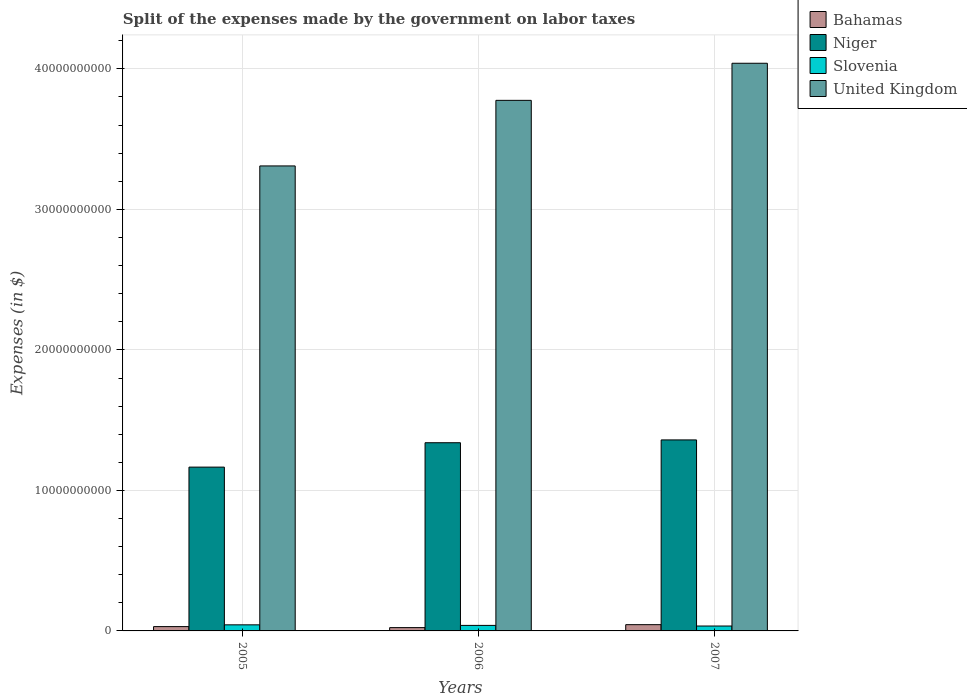How many bars are there on the 1st tick from the left?
Your answer should be compact. 4. How many bars are there on the 2nd tick from the right?
Your response must be concise. 4. What is the label of the 3rd group of bars from the left?
Keep it short and to the point. 2007. What is the expenses made by the government on labor taxes in Bahamas in 2006?
Keep it short and to the point. 2.35e+08. Across all years, what is the maximum expenses made by the government on labor taxes in Slovenia?
Your response must be concise. 4.33e+08. Across all years, what is the minimum expenses made by the government on labor taxes in Niger?
Give a very brief answer. 1.17e+1. In which year was the expenses made by the government on labor taxes in Niger minimum?
Offer a terse response. 2005. What is the total expenses made by the government on labor taxes in Niger in the graph?
Keep it short and to the point. 3.86e+1. What is the difference between the expenses made by the government on labor taxes in Bahamas in 2005 and that in 2007?
Keep it short and to the point. -1.39e+08. What is the difference between the expenses made by the government on labor taxes in United Kingdom in 2007 and the expenses made by the government on labor taxes in Niger in 2006?
Your answer should be very brief. 2.70e+1. What is the average expenses made by the government on labor taxes in Slovenia per year?
Offer a very short reply. 3.91e+08. In the year 2006, what is the difference between the expenses made by the government on labor taxes in Bahamas and expenses made by the government on labor taxes in Slovenia?
Ensure brevity in your answer.  -1.58e+08. What is the ratio of the expenses made by the government on labor taxes in United Kingdom in 2006 to that in 2007?
Keep it short and to the point. 0.93. Is the expenses made by the government on labor taxes in Niger in 2006 less than that in 2007?
Ensure brevity in your answer.  Yes. Is the difference between the expenses made by the government on labor taxes in Bahamas in 2005 and 2006 greater than the difference between the expenses made by the government on labor taxes in Slovenia in 2005 and 2006?
Your response must be concise. Yes. What is the difference between the highest and the second highest expenses made by the government on labor taxes in United Kingdom?
Give a very brief answer. 2.64e+09. What is the difference between the highest and the lowest expenses made by the government on labor taxes in United Kingdom?
Keep it short and to the point. 7.31e+09. In how many years, is the expenses made by the government on labor taxes in Bahamas greater than the average expenses made by the government on labor taxes in Bahamas taken over all years?
Offer a very short reply. 1. Is it the case that in every year, the sum of the expenses made by the government on labor taxes in United Kingdom and expenses made by the government on labor taxes in Slovenia is greater than the sum of expenses made by the government on labor taxes in Niger and expenses made by the government on labor taxes in Bahamas?
Offer a terse response. Yes. What does the 4th bar from the right in 2006 represents?
Offer a very short reply. Bahamas. How many years are there in the graph?
Ensure brevity in your answer.  3. Does the graph contain any zero values?
Your answer should be very brief. No. Does the graph contain grids?
Your answer should be compact. Yes. Where does the legend appear in the graph?
Provide a short and direct response. Top right. How many legend labels are there?
Your response must be concise. 4. What is the title of the graph?
Ensure brevity in your answer.  Split of the expenses made by the government on labor taxes. Does "Monaco" appear as one of the legend labels in the graph?
Give a very brief answer. No. What is the label or title of the Y-axis?
Offer a terse response. Expenses (in $). What is the Expenses (in $) of Bahamas in 2005?
Your response must be concise. 3.07e+08. What is the Expenses (in $) in Niger in 2005?
Ensure brevity in your answer.  1.17e+1. What is the Expenses (in $) of Slovenia in 2005?
Your answer should be very brief. 4.33e+08. What is the Expenses (in $) of United Kingdom in 2005?
Your answer should be compact. 3.31e+1. What is the Expenses (in $) of Bahamas in 2006?
Ensure brevity in your answer.  2.35e+08. What is the Expenses (in $) in Niger in 2006?
Ensure brevity in your answer.  1.34e+1. What is the Expenses (in $) of Slovenia in 2006?
Your response must be concise. 3.93e+08. What is the Expenses (in $) of United Kingdom in 2006?
Offer a very short reply. 3.78e+1. What is the Expenses (in $) in Bahamas in 2007?
Keep it short and to the point. 4.46e+08. What is the Expenses (in $) of Niger in 2007?
Ensure brevity in your answer.  1.36e+1. What is the Expenses (in $) of Slovenia in 2007?
Provide a short and direct response. 3.49e+08. What is the Expenses (in $) in United Kingdom in 2007?
Provide a succinct answer. 4.04e+1. Across all years, what is the maximum Expenses (in $) of Bahamas?
Give a very brief answer. 4.46e+08. Across all years, what is the maximum Expenses (in $) in Niger?
Offer a terse response. 1.36e+1. Across all years, what is the maximum Expenses (in $) in Slovenia?
Keep it short and to the point. 4.33e+08. Across all years, what is the maximum Expenses (in $) of United Kingdom?
Your answer should be very brief. 4.04e+1. Across all years, what is the minimum Expenses (in $) in Bahamas?
Offer a terse response. 2.35e+08. Across all years, what is the minimum Expenses (in $) of Niger?
Give a very brief answer. 1.17e+1. Across all years, what is the minimum Expenses (in $) of Slovenia?
Your answer should be compact. 3.49e+08. Across all years, what is the minimum Expenses (in $) of United Kingdom?
Offer a very short reply. 3.31e+1. What is the total Expenses (in $) in Bahamas in the graph?
Give a very brief answer. 9.88e+08. What is the total Expenses (in $) in Niger in the graph?
Offer a very short reply. 3.86e+1. What is the total Expenses (in $) in Slovenia in the graph?
Give a very brief answer. 1.17e+09. What is the total Expenses (in $) in United Kingdom in the graph?
Make the answer very short. 1.11e+11. What is the difference between the Expenses (in $) in Bahamas in 2005 and that in 2006?
Give a very brief answer. 7.18e+07. What is the difference between the Expenses (in $) of Niger in 2005 and that in 2006?
Your response must be concise. -1.74e+09. What is the difference between the Expenses (in $) of Slovenia in 2005 and that in 2006?
Ensure brevity in your answer.  3.99e+07. What is the difference between the Expenses (in $) in United Kingdom in 2005 and that in 2006?
Keep it short and to the point. -4.67e+09. What is the difference between the Expenses (in $) in Bahamas in 2005 and that in 2007?
Offer a very short reply. -1.39e+08. What is the difference between the Expenses (in $) of Niger in 2005 and that in 2007?
Keep it short and to the point. -1.94e+09. What is the difference between the Expenses (in $) in Slovenia in 2005 and that in 2007?
Make the answer very short. 8.39e+07. What is the difference between the Expenses (in $) of United Kingdom in 2005 and that in 2007?
Offer a very short reply. -7.31e+09. What is the difference between the Expenses (in $) of Bahamas in 2006 and that in 2007?
Your response must be concise. -2.10e+08. What is the difference between the Expenses (in $) of Niger in 2006 and that in 2007?
Provide a short and direct response. -2.01e+08. What is the difference between the Expenses (in $) in Slovenia in 2006 and that in 2007?
Offer a terse response. 4.41e+07. What is the difference between the Expenses (in $) of United Kingdom in 2006 and that in 2007?
Offer a very short reply. -2.64e+09. What is the difference between the Expenses (in $) in Bahamas in 2005 and the Expenses (in $) in Niger in 2006?
Keep it short and to the point. -1.31e+1. What is the difference between the Expenses (in $) of Bahamas in 2005 and the Expenses (in $) of Slovenia in 2006?
Keep it short and to the point. -8.58e+07. What is the difference between the Expenses (in $) of Bahamas in 2005 and the Expenses (in $) of United Kingdom in 2006?
Offer a terse response. -3.75e+1. What is the difference between the Expenses (in $) of Niger in 2005 and the Expenses (in $) of Slovenia in 2006?
Your response must be concise. 1.13e+1. What is the difference between the Expenses (in $) in Niger in 2005 and the Expenses (in $) in United Kingdom in 2006?
Offer a very short reply. -2.61e+1. What is the difference between the Expenses (in $) of Slovenia in 2005 and the Expenses (in $) of United Kingdom in 2006?
Your answer should be compact. -3.73e+1. What is the difference between the Expenses (in $) in Bahamas in 2005 and the Expenses (in $) in Niger in 2007?
Offer a very short reply. -1.33e+1. What is the difference between the Expenses (in $) in Bahamas in 2005 and the Expenses (in $) in Slovenia in 2007?
Provide a succinct answer. -4.17e+07. What is the difference between the Expenses (in $) in Bahamas in 2005 and the Expenses (in $) in United Kingdom in 2007?
Your answer should be compact. -4.01e+1. What is the difference between the Expenses (in $) of Niger in 2005 and the Expenses (in $) of Slovenia in 2007?
Your answer should be very brief. 1.13e+1. What is the difference between the Expenses (in $) of Niger in 2005 and the Expenses (in $) of United Kingdom in 2007?
Your answer should be compact. -2.87e+1. What is the difference between the Expenses (in $) of Slovenia in 2005 and the Expenses (in $) of United Kingdom in 2007?
Your answer should be very brief. -4.00e+1. What is the difference between the Expenses (in $) of Bahamas in 2006 and the Expenses (in $) of Niger in 2007?
Provide a short and direct response. -1.34e+1. What is the difference between the Expenses (in $) in Bahamas in 2006 and the Expenses (in $) in Slovenia in 2007?
Your response must be concise. -1.14e+08. What is the difference between the Expenses (in $) in Bahamas in 2006 and the Expenses (in $) in United Kingdom in 2007?
Provide a succinct answer. -4.02e+1. What is the difference between the Expenses (in $) in Niger in 2006 and the Expenses (in $) in Slovenia in 2007?
Your response must be concise. 1.30e+1. What is the difference between the Expenses (in $) of Niger in 2006 and the Expenses (in $) of United Kingdom in 2007?
Ensure brevity in your answer.  -2.70e+1. What is the difference between the Expenses (in $) in Slovenia in 2006 and the Expenses (in $) in United Kingdom in 2007?
Provide a short and direct response. -4.00e+1. What is the average Expenses (in $) of Bahamas per year?
Your response must be concise. 3.29e+08. What is the average Expenses (in $) of Niger per year?
Your answer should be compact. 1.29e+1. What is the average Expenses (in $) of Slovenia per year?
Make the answer very short. 3.91e+08. What is the average Expenses (in $) in United Kingdom per year?
Make the answer very short. 3.71e+1. In the year 2005, what is the difference between the Expenses (in $) of Bahamas and Expenses (in $) of Niger?
Provide a short and direct response. -1.14e+1. In the year 2005, what is the difference between the Expenses (in $) in Bahamas and Expenses (in $) in Slovenia?
Give a very brief answer. -1.26e+08. In the year 2005, what is the difference between the Expenses (in $) of Bahamas and Expenses (in $) of United Kingdom?
Your answer should be compact. -3.28e+1. In the year 2005, what is the difference between the Expenses (in $) of Niger and Expenses (in $) of Slovenia?
Ensure brevity in your answer.  1.12e+1. In the year 2005, what is the difference between the Expenses (in $) in Niger and Expenses (in $) in United Kingdom?
Offer a very short reply. -2.14e+1. In the year 2005, what is the difference between the Expenses (in $) in Slovenia and Expenses (in $) in United Kingdom?
Give a very brief answer. -3.27e+1. In the year 2006, what is the difference between the Expenses (in $) in Bahamas and Expenses (in $) in Niger?
Provide a short and direct response. -1.32e+1. In the year 2006, what is the difference between the Expenses (in $) in Bahamas and Expenses (in $) in Slovenia?
Give a very brief answer. -1.58e+08. In the year 2006, what is the difference between the Expenses (in $) of Bahamas and Expenses (in $) of United Kingdom?
Your answer should be compact. -3.75e+1. In the year 2006, what is the difference between the Expenses (in $) of Niger and Expenses (in $) of Slovenia?
Your response must be concise. 1.30e+1. In the year 2006, what is the difference between the Expenses (in $) in Niger and Expenses (in $) in United Kingdom?
Provide a succinct answer. -2.44e+1. In the year 2006, what is the difference between the Expenses (in $) in Slovenia and Expenses (in $) in United Kingdom?
Your answer should be compact. -3.74e+1. In the year 2007, what is the difference between the Expenses (in $) of Bahamas and Expenses (in $) of Niger?
Ensure brevity in your answer.  -1.31e+1. In the year 2007, what is the difference between the Expenses (in $) in Bahamas and Expenses (in $) in Slovenia?
Your answer should be very brief. 9.68e+07. In the year 2007, what is the difference between the Expenses (in $) in Bahamas and Expenses (in $) in United Kingdom?
Your answer should be very brief. -4.00e+1. In the year 2007, what is the difference between the Expenses (in $) in Niger and Expenses (in $) in Slovenia?
Ensure brevity in your answer.  1.32e+1. In the year 2007, what is the difference between the Expenses (in $) in Niger and Expenses (in $) in United Kingdom?
Provide a succinct answer. -2.68e+1. In the year 2007, what is the difference between the Expenses (in $) of Slovenia and Expenses (in $) of United Kingdom?
Keep it short and to the point. -4.01e+1. What is the ratio of the Expenses (in $) of Bahamas in 2005 to that in 2006?
Make the answer very short. 1.31. What is the ratio of the Expenses (in $) of Niger in 2005 to that in 2006?
Ensure brevity in your answer.  0.87. What is the ratio of the Expenses (in $) of Slovenia in 2005 to that in 2006?
Your answer should be compact. 1.1. What is the ratio of the Expenses (in $) in United Kingdom in 2005 to that in 2006?
Give a very brief answer. 0.88. What is the ratio of the Expenses (in $) of Bahamas in 2005 to that in 2007?
Your answer should be very brief. 0.69. What is the ratio of the Expenses (in $) of Niger in 2005 to that in 2007?
Keep it short and to the point. 0.86. What is the ratio of the Expenses (in $) in Slovenia in 2005 to that in 2007?
Give a very brief answer. 1.24. What is the ratio of the Expenses (in $) of United Kingdom in 2005 to that in 2007?
Offer a terse response. 0.82. What is the ratio of the Expenses (in $) in Bahamas in 2006 to that in 2007?
Offer a terse response. 0.53. What is the ratio of the Expenses (in $) in Niger in 2006 to that in 2007?
Provide a succinct answer. 0.99. What is the ratio of the Expenses (in $) in Slovenia in 2006 to that in 2007?
Your answer should be compact. 1.13. What is the ratio of the Expenses (in $) in United Kingdom in 2006 to that in 2007?
Ensure brevity in your answer.  0.93. What is the difference between the highest and the second highest Expenses (in $) in Bahamas?
Give a very brief answer. 1.39e+08. What is the difference between the highest and the second highest Expenses (in $) in Niger?
Your answer should be very brief. 2.01e+08. What is the difference between the highest and the second highest Expenses (in $) in Slovenia?
Offer a terse response. 3.99e+07. What is the difference between the highest and the second highest Expenses (in $) of United Kingdom?
Provide a succinct answer. 2.64e+09. What is the difference between the highest and the lowest Expenses (in $) of Bahamas?
Keep it short and to the point. 2.10e+08. What is the difference between the highest and the lowest Expenses (in $) in Niger?
Your answer should be very brief. 1.94e+09. What is the difference between the highest and the lowest Expenses (in $) in Slovenia?
Your answer should be compact. 8.39e+07. What is the difference between the highest and the lowest Expenses (in $) of United Kingdom?
Provide a succinct answer. 7.31e+09. 